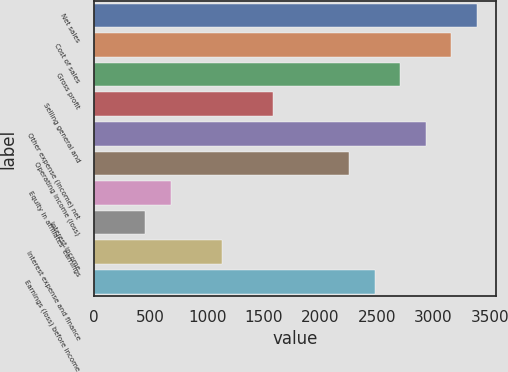Convert chart to OTSL. <chart><loc_0><loc_0><loc_500><loc_500><bar_chart><fcel>Net sales<fcel>Cost of sales<fcel>Gross profit<fcel>Selling general and<fcel>Other expense (income) net<fcel>Operating income (loss)<fcel>Equity in affiliates' earnings<fcel>Interest income<fcel>Interest expense and finance<fcel>Earnings (loss) before income<nl><fcel>3387.79<fcel>3162.03<fcel>2710.51<fcel>1581.71<fcel>2936.27<fcel>2258.99<fcel>678.67<fcel>452.91<fcel>1130.19<fcel>2484.75<nl></chart> 